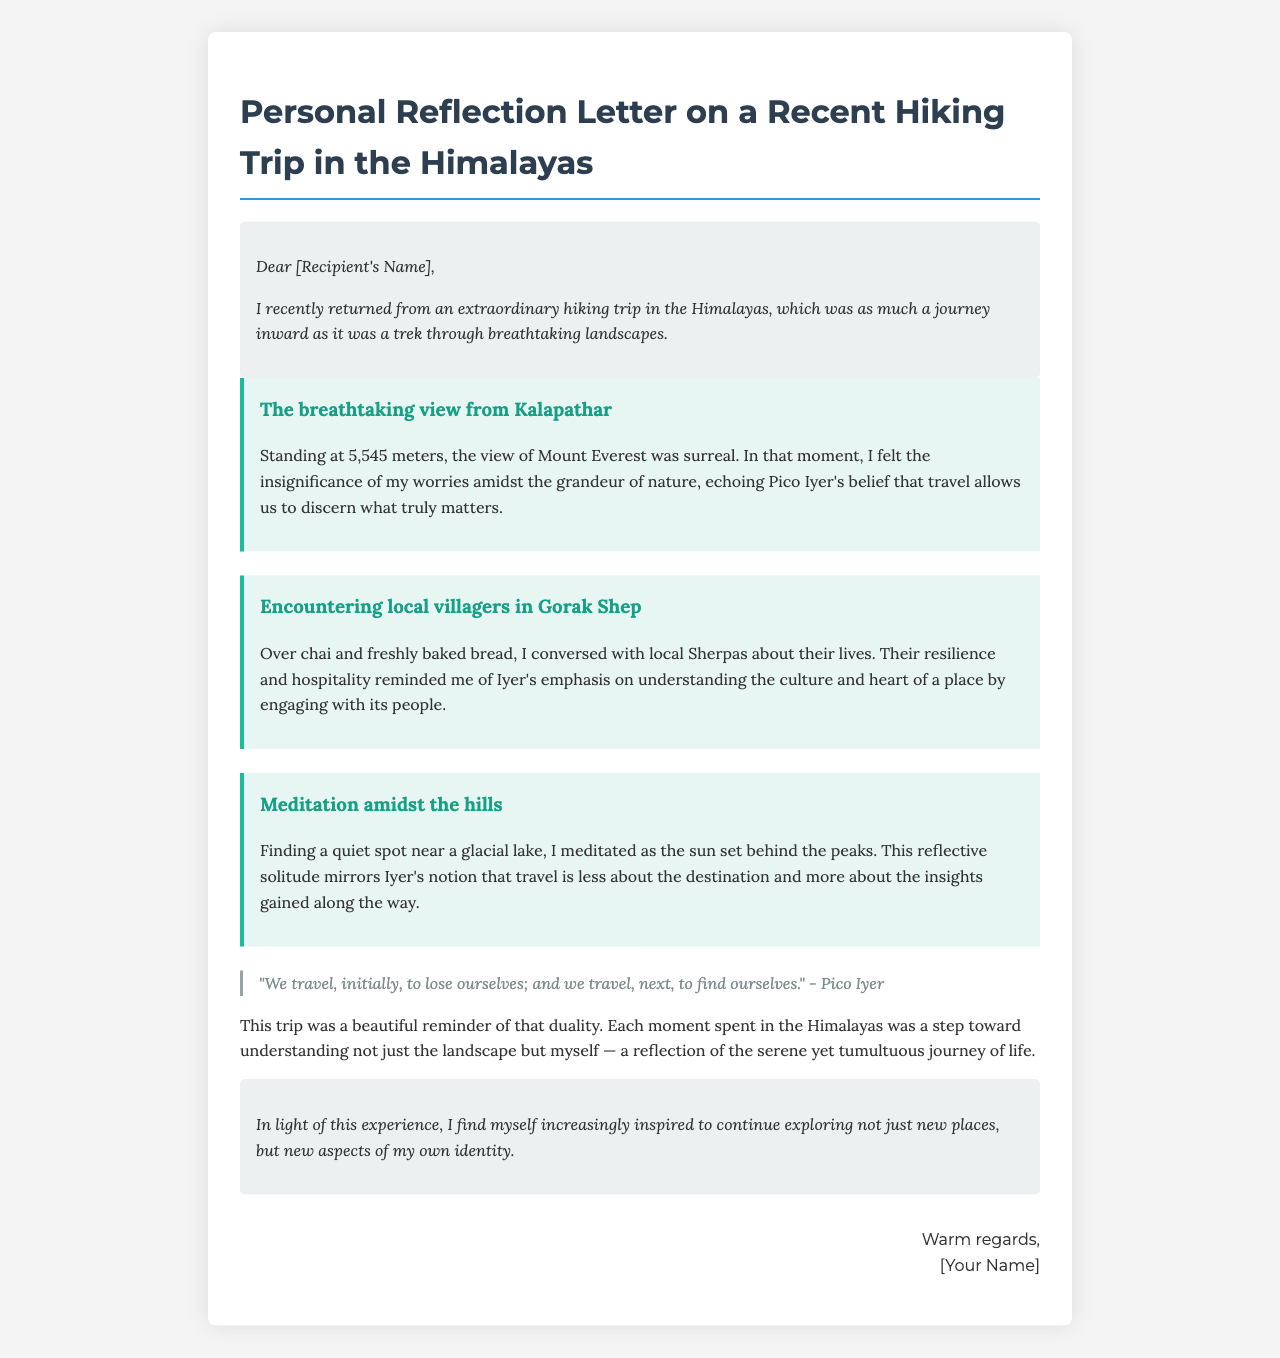What is the title of the letter? The title is clearly indicated at the beginning of the document, summarizing the essence of the content.
Answer: Personal Reflection Letter on a Recent Hiking Trip in the Himalayas What is the recipient's greeting in the letter? The letter starts with a greeting addressed to the recipient, which is a common element in personal letters.
Answer: Dear [Recipient's Name] What is the highest point mentioned in the document? The highest elevation referenced is at Kalapathar, where a breathtaking view is described.
Answer: 5,545 meters Who did the author have tea with in Gorak Shep? The letter describes a friendly interaction, indicating the people the author engaged with during the trip.
Answer: Local Sherpas What philosophical belief of Pico Iyer is referenced in the letter? The author draws on Iyer's thoughts about the purpose of travel, linking it to personal insight.
Answer: Travel allows us to discern what truly matters What natural feature did the author meditate near? The letter specifies a serene location the author chose for meditation during the experience.
Answer: A glacial lake What did the author feel standing at Kalapathar? The author reflects on their emotional state when faced with the grandeur of nature during the hike.
Answer: Insignificance of worries What does the author intend to explore in the future? The conclusion specifies what the author hopes to pursue following their reflective experience in the Himalayas.
Answer: New aspects of my own identity 